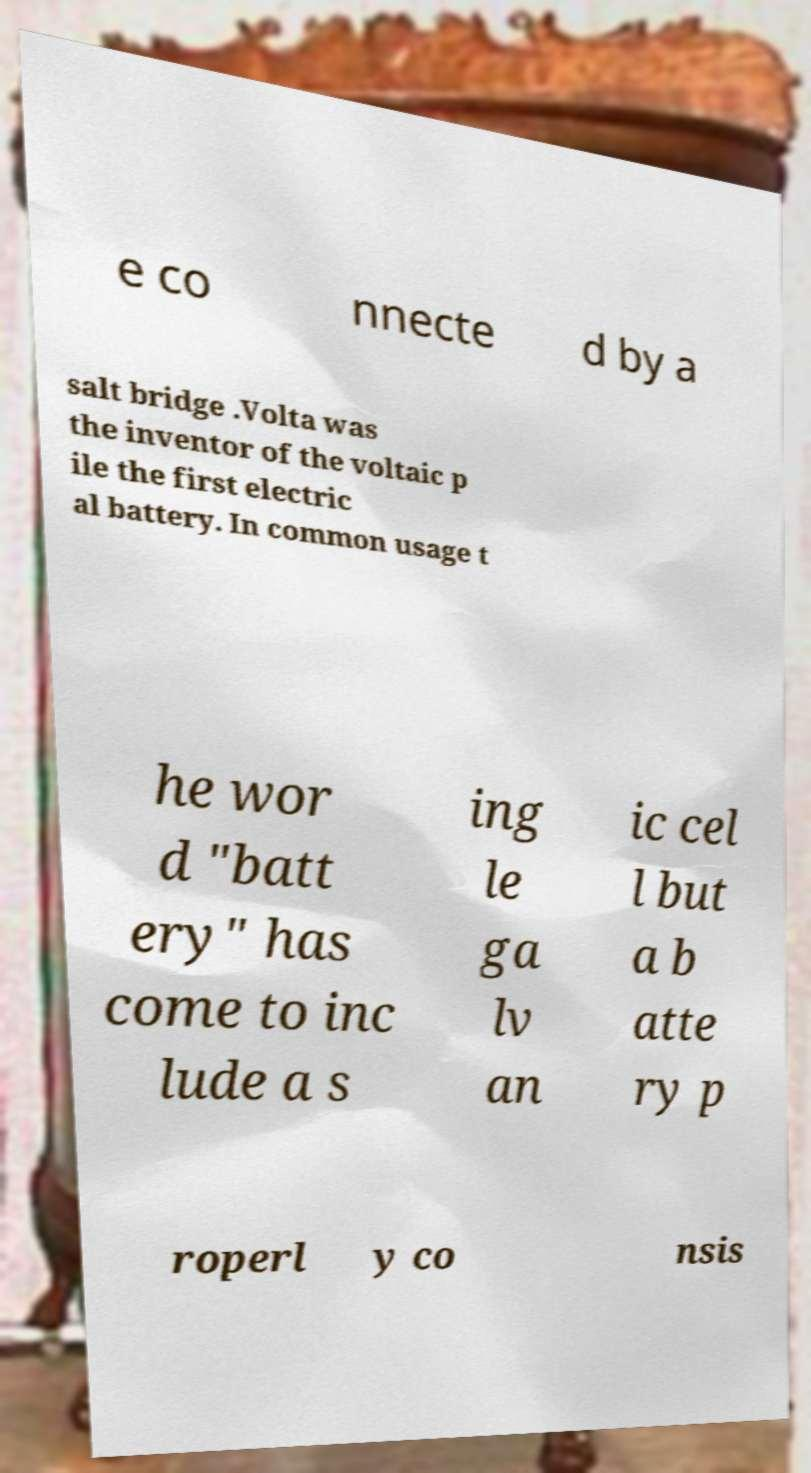Could you extract and type out the text from this image? e co nnecte d by a salt bridge .Volta was the inventor of the voltaic p ile the first electric al battery. In common usage t he wor d "batt ery" has come to inc lude a s ing le ga lv an ic cel l but a b atte ry p roperl y co nsis 